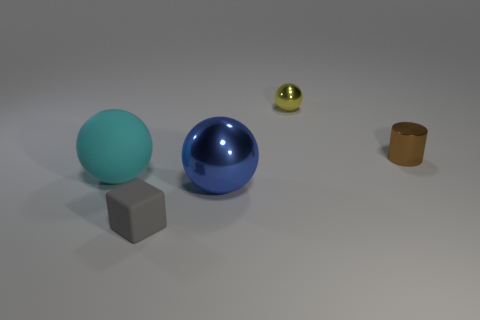Does the big matte object have the same color as the small shiny sphere?
Offer a terse response. No. What number of gray objects are in front of the tiny brown shiny cylinder right of the big sphere behind the large blue ball?
Ensure brevity in your answer.  1. How big is the metallic cylinder?
Offer a terse response. Small. What is the material of the blue object that is the same size as the cyan object?
Provide a short and direct response. Metal. There is a tiny gray matte block; how many tiny brown shiny cylinders are left of it?
Offer a very short reply. 0. Do the large object that is in front of the cyan sphere and the small object behind the cylinder have the same material?
Your answer should be very brief. Yes. The metallic object that is right of the object that is behind the tiny shiny thing that is to the right of the small yellow metallic ball is what shape?
Provide a succinct answer. Cylinder. The cyan thing has what shape?
Your response must be concise. Sphere. What shape is the cyan matte object that is the same size as the blue sphere?
Give a very brief answer. Sphere. How many other things are there of the same color as the small ball?
Offer a very short reply. 0. 